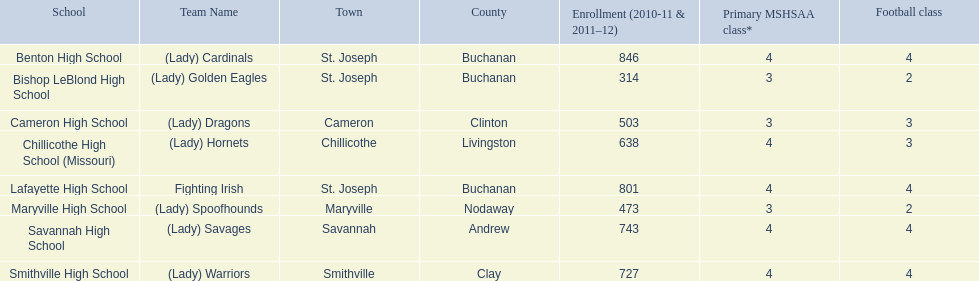What squad has green and grey as their shades? Fighting Irish. What is this squad referred to as? Lafayette High School. 